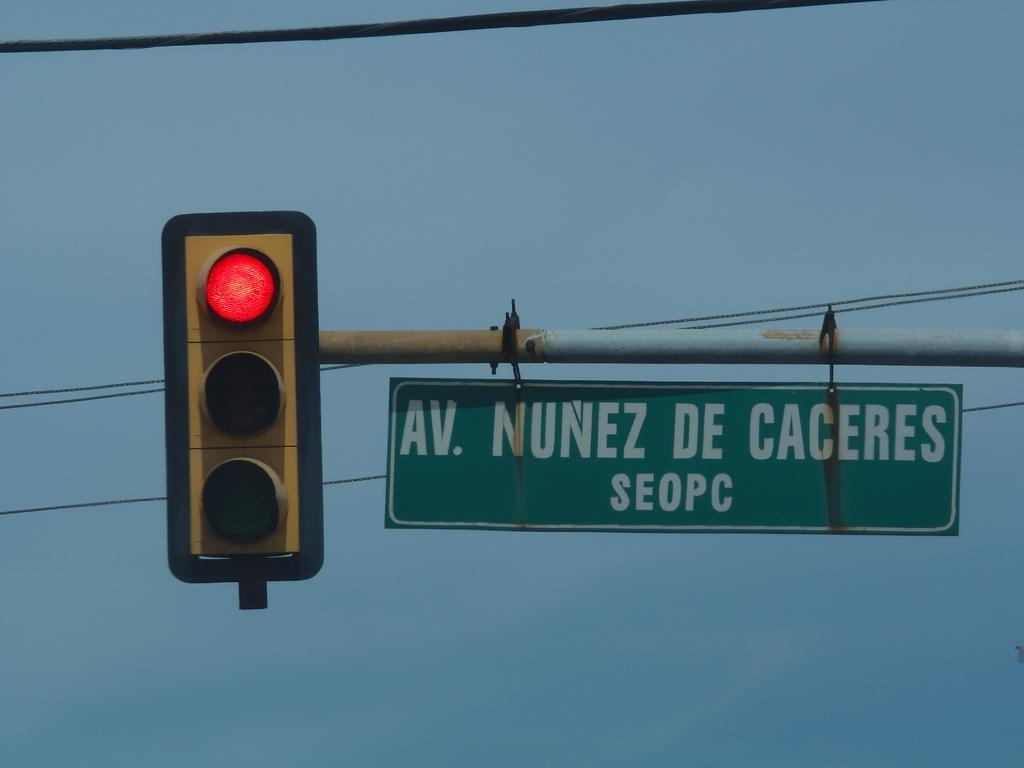Provide a one-sentence caption for the provided image. A stop light by a sign saying AV NUNEZ DE CACERES. 